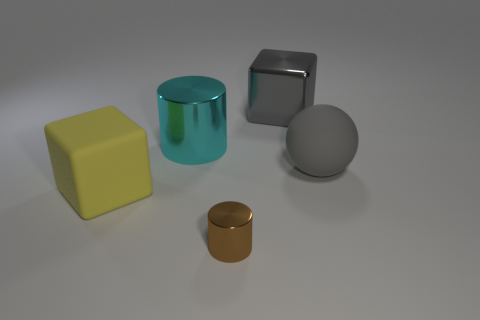Add 5 big red cylinders. How many objects exist? 10 Subtract all cubes. How many objects are left? 3 Add 4 rubber balls. How many rubber balls are left? 5 Add 5 big blocks. How many big blocks exist? 7 Subtract 0 cyan cubes. How many objects are left? 5 Subtract all big blue rubber blocks. Subtract all gray things. How many objects are left? 3 